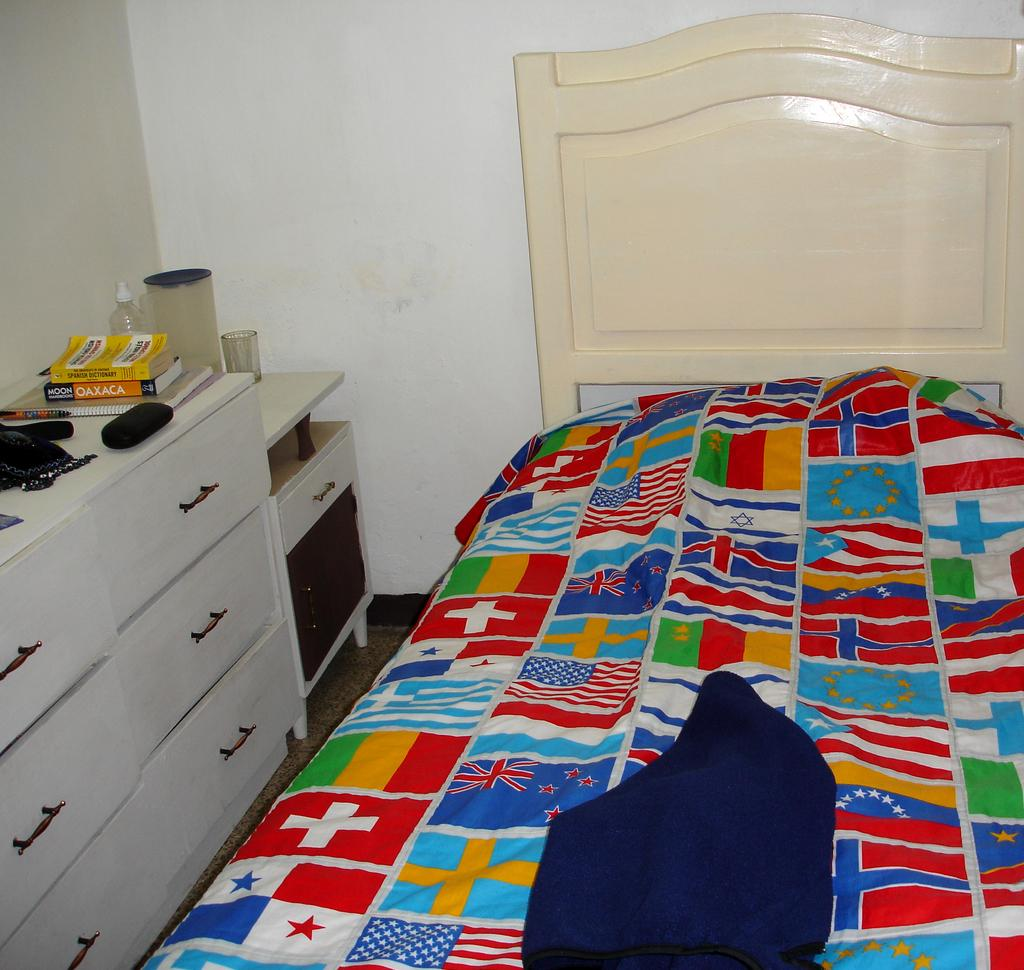What type of furniture is present in the image? There is a bed in the image. What type of storage is present in the image? There are drawers in the image. What items can be seen related to reading or learning? There are books in the image. What type of containers are present in the image? There is a bottle and a glass in the image. What is covering the bed in the image? There is cloth on the bed in the image. What can be seen in the background of the image? There is a wall in the background of the image. How does the son interact with the patch in the image? There is no son or patch present in the image. 